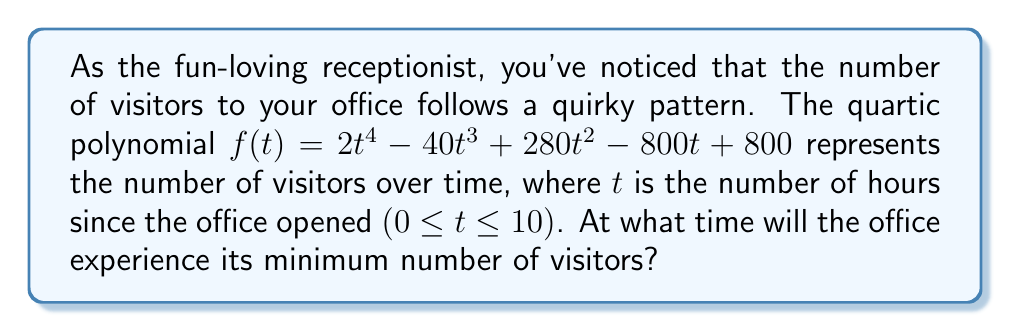What is the answer to this math problem? To find the minimum number of visitors, we need to determine when the derivative of the function equals zero and confirm it's a local minimum.

1) First, let's find the derivative of $f(t)$:
   $f'(t) = 8t^3 - 120t^2 + 560t - 800$

2) Set the derivative equal to zero:
   $8t^3 - 120t^2 + 560t - 800 = 0$

3) This is a cubic equation. Let's factor out the greatest common factor:
   $8(t^3 - 15t^2 + 70t - 100) = 0$

4) The rational root theorem suggests potential roots: ±1, ±2, ±4, ±5, ±10, ±20, ±25, ±50, ±100
   By testing, we find that $t = 5$ is a solution.

5) Factoring further:
   $8(t - 5)(t^2 - 10t + 20) = 0$

6) Using the quadratic formula for $t^2 - 10t + 20 = 0$:
   $t = \frac{10 \pm \sqrt{100 - 80}}{2} = \frac{10 \pm \sqrt{20}}{2}$

7) These solutions are not in the domain of $0 \leq t \leq 10$, so $t = 5$ is our only valid solution.

8) To confirm it's a minimum, check the second derivative:
   $f''(t) = 24t^2 - 240t + 560$
   $f''(5) = 24(25) - 240(5) + 560 = 600 - 1200 + 560 = -40$

   Since $f''(5)$ is negative, $t = 5$ is indeed a local maximum.

Therefore, the minimum occurs at $t = 5$ hours after the office opens.
Answer: 5 hours 